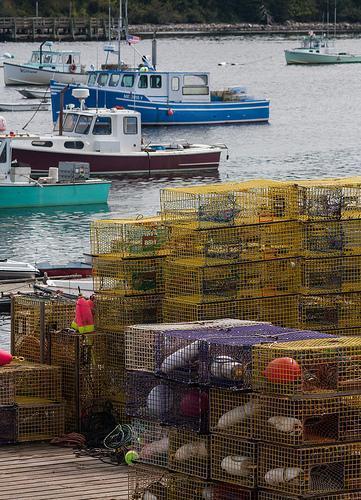How many boats are sailing?
Give a very brief answer. 5. 